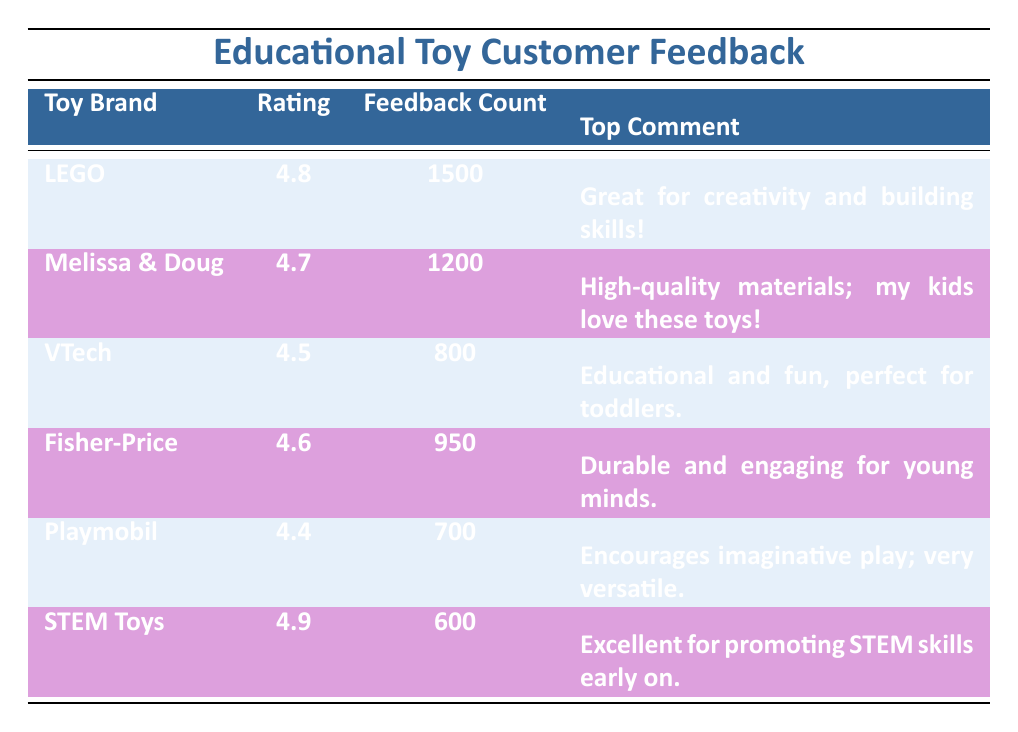What is the highest customer feedback rating among the toys listed? The table shows the ratings for various toy brands. By comparing the ratings, we see that LEGO has a rating of 4.8, which is the highest of all the brands listed.
Answer: 4.8 Which toy brand has the lowest feedback count? The feedback counts for each toy brand are as follows: LEGO (1500), Melissa & Doug (1200), VTech (800), Fisher-Price (950), Playmobil (700), and STEM Toys (600). Comparing these numbers, Playmobil has the lowest feedback count of 700.
Answer: Playmobil Is the top comment for VTech positive? The top comment provided for VTech states, "Educational and fun, perfect for toddlers." This statement reflects a positive sentiment regarding the toy.
Answer: Yes What is the average rating of all the toy brands shown in the table? To calculate the average rating, we first list the ratings: 4.8 (LEGO), 4.7 (Melissa & Doug), 4.5 (VTech), 4.6 (Fisher-Price), 4.4 (Playmobil), and 4.9 (STEM Toys). Adding these gives a total of 27.9. Dividing by the number of brands (6), we find the average rating is 27.9 / 6 = 4.65.
Answer: 4.65 How many more feedback comments does LEGO have compared to Playmobil? LEGO has 1500 feedback comments, while Playmobil has 700. To find the difference, we subtract Playmobil's count from LEGO's: 1500 - 700 = 800.
Answer: 800 Which brand has the best top comment, based on sentiment, and what is it? The sentiment in the comments shows LEGO's top comment as "Great for creativity and building skills!" and STEM Toys' comment as "Excellent for promoting STEM skills early on." Both are very positive, but LEGO's comment emphasizes creativity, which is often seen as highly valuable. So, LEGO's top comment is judged best for sentiment.
Answer: LEGO Is the rating for STEM Toys higher than Fisher-Price? The rating for STEM Toys is 4.9, while the rating for Fisher-Price is 4.6. Therefore, STEM Toys has a higher rating than Fisher-Price.
Answer: Yes Which toy brands have feedback ratings above 4.5? The ratings above 4.5 are: LEGO (4.8), Melissa & Doug (4.7), Fisher-Price (4.6), and STEM Toys (4.9). Thus, the brands with ratings above 4.5 are LEGO, Melissa & Doug, Fisher-Price, and STEM Toys.
Answer: LEGO, Melissa & Doug, Fisher-Price, STEM Toys What percentage of total feedback comments do the comments for VTech represent? The total feedback comments across all brands is 1500 + 1200 + 800 + 950 + 700 + 600 = 4750. The feedback count for VTech is 800. To find the percentage, we calculate (800 / 4750) * 100, which gives approximately 16.84%.
Answer: 16.84% 